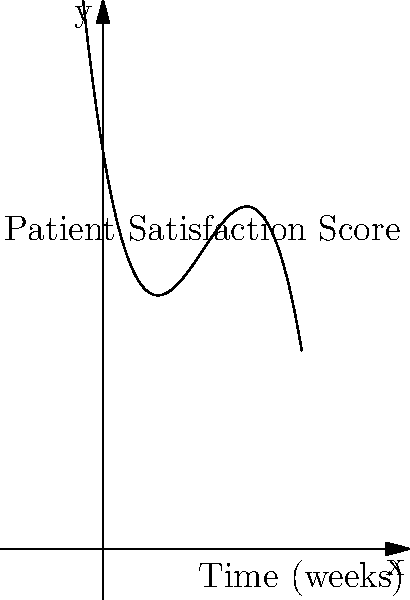As a mental health advocate, you're analyzing a polynomial function representing patient satisfaction scores over time in a psychiatric facility. The function is given by $f(x) = -0.1x^3 + 1.5x^2 - 6x + 20$, where $x$ represents the number of weeks and $f(x)$ represents the average satisfaction score. Based on the graph, at approximately how many weeks does the patient satisfaction score reach its maximum? To find the maximum point of the polynomial function, we need to follow these steps:

1. Observe the graph: The curve starts at a high point, decreases, then increases to a peak before decreasing again.

2. Identify the turning points: There are two turning points - one minimum and one maximum.

3. Locate the maximum: The maximum point is the higher of the two turning points.

4. Estimate the x-coordinate: The maximum appears to occur between 5 and 6 weeks on the x-axis.

5. Verify mathematically (optional):
   - Find the derivative: $f'(x) = -0.3x^2 + 3x - 6$
   - Set $f'(x) = 0$ and solve:
     $-0.3x^2 + 3x - 6 = 0$
     $x = \frac{3 \pm \sqrt{9 + 7.2}}{-0.6} \approx 5.73$ or $3.27$
   - The larger value, 5.73, corresponds to the maximum.

6. Round to the nearest whole number: 5.73 rounds to 6 weeks.

Therefore, the patient satisfaction score reaches its maximum at approximately 6 weeks.
Answer: 6 weeks 